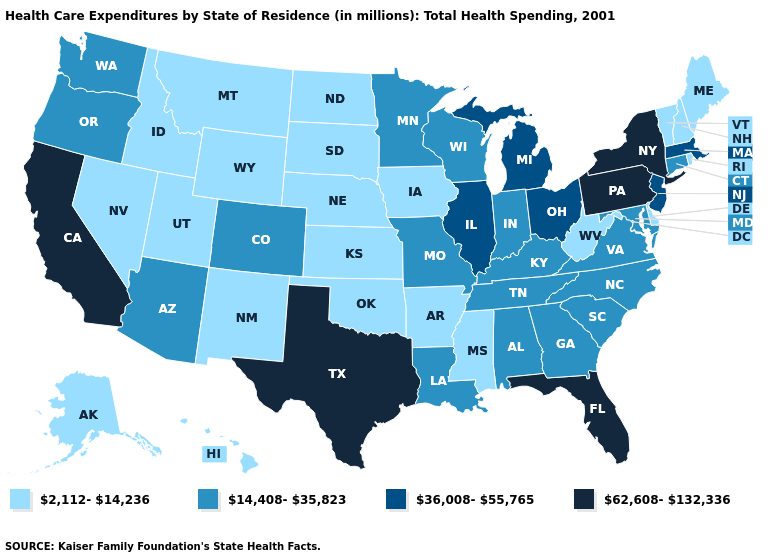What is the highest value in states that border Texas?
Answer briefly. 14,408-35,823. Name the states that have a value in the range 62,608-132,336?
Concise answer only. California, Florida, New York, Pennsylvania, Texas. Does Florida have the highest value in the USA?
Answer briefly. Yes. What is the value of New Jersey?
Be succinct. 36,008-55,765. Does Delaware have a higher value than Connecticut?
Be succinct. No. What is the value of California?
Give a very brief answer. 62,608-132,336. What is the value of Nebraska?
Short answer required. 2,112-14,236. What is the value of Alabama?
Keep it brief. 14,408-35,823. Does Wisconsin have the same value as Michigan?
Keep it brief. No. Name the states that have a value in the range 14,408-35,823?
Concise answer only. Alabama, Arizona, Colorado, Connecticut, Georgia, Indiana, Kentucky, Louisiana, Maryland, Minnesota, Missouri, North Carolina, Oregon, South Carolina, Tennessee, Virginia, Washington, Wisconsin. What is the lowest value in the West?
Write a very short answer. 2,112-14,236. Among the states that border Arizona , which have the highest value?
Answer briefly. California. Name the states that have a value in the range 2,112-14,236?
Be succinct. Alaska, Arkansas, Delaware, Hawaii, Idaho, Iowa, Kansas, Maine, Mississippi, Montana, Nebraska, Nevada, New Hampshire, New Mexico, North Dakota, Oklahoma, Rhode Island, South Dakota, Utah, Vermont, West Virginia, Wyoming. Among the states that border South Carolina , which have the highest value?
Quick response, please. Georgia, North Carolina. 